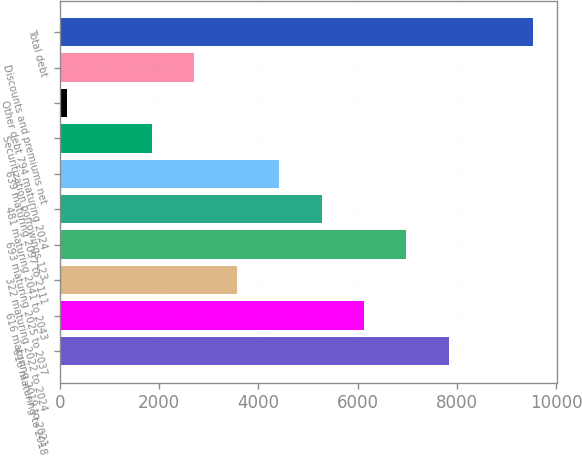<chart> <loc_0><loc_0><loc_500><loc_500><bar_chart><fcel>616 maturing to 2018<fcel>616 maturing 2019 to 2021<fcel>322 maturing 2022 to 2024<fcel>693 maturing 2025 to 2037<fcel>481 maturing 2041 to 2043<fcel>639 maturing 2097 to 2111<fcel>Securitization borrowings 123<fcel>Other debt 794 maturing 2024<fcel>Discounts and premiums net<fcel>Total debt<nl><fcel>7828.9<fcel>6122.7<fcel>3563.4<fcel>6975.8<fcel>5269.6<fcel>4416.5<fcel>1857.2<fcel>151<fcel>2710.3<fcel>9535.1<nl></chart> 